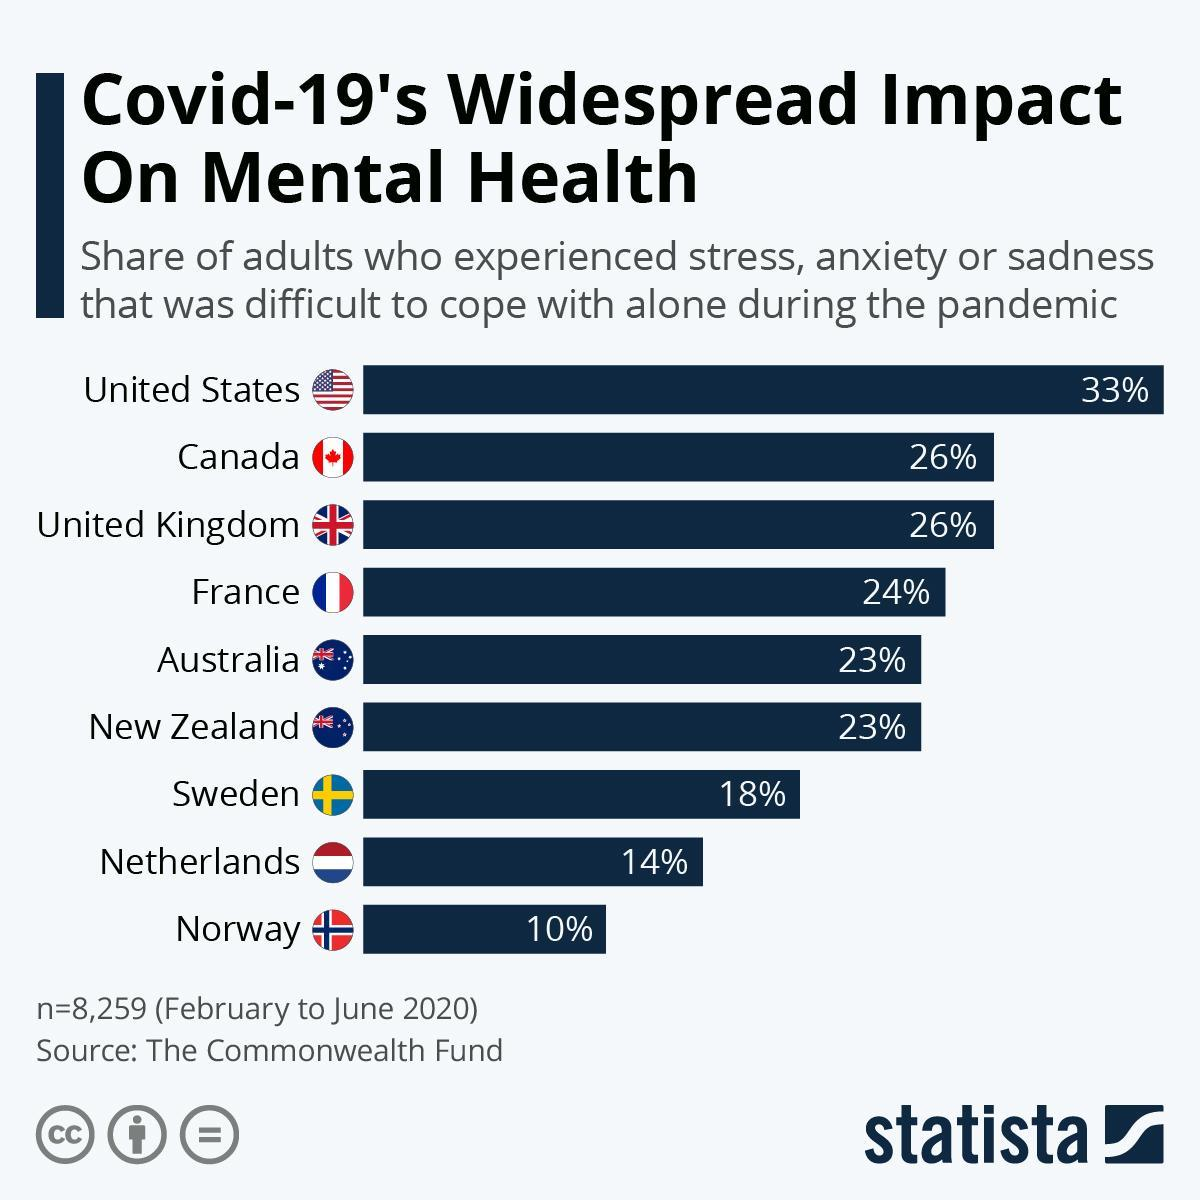When was the survey taken?
Answer the question with a short phrase. February to June 2020 Canada and which other country share the same percentage of adults experiencing stress? United Kingdom What percent of adults in Netherlands and Norway experienced stress and anxiety? 24% How many adults were surveyed? 8,259 